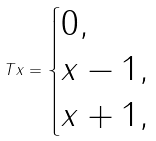Convert formula to latex. <formula><loc_0><loc_0><loc_500><loc_500>T x = \begin{cases} 0 , & \\ x - 1 , & \\ x + 1 , & \end{cases}</formula> 